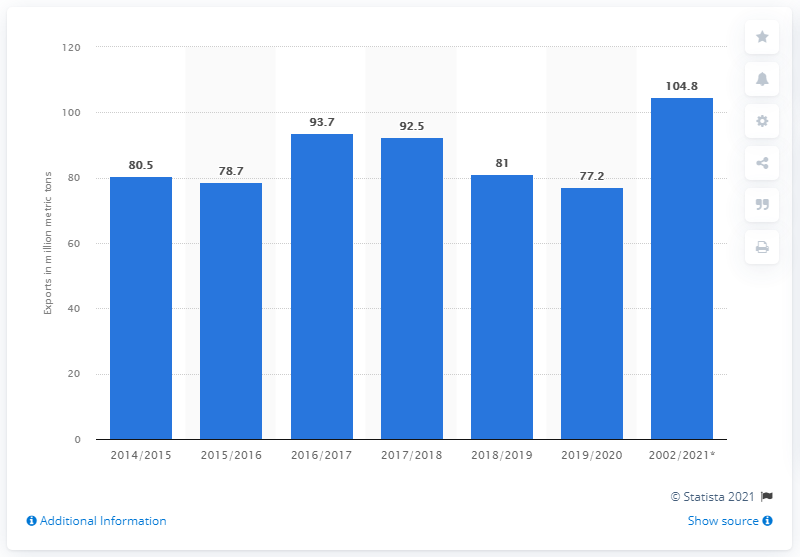Specify some key components in this picture. During the fiscal year 2016/2017, a total of 92.5 million metric tons of grain was exported from the United States. 